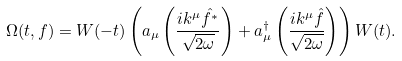Convert formula to latex. <formula><loc_0><loc_0><loc_500><loc_500>\Omega ( t , f ) = W ( - t ) \left ( a _ { \mu } \left ( \frac { i k ^ { \mu } \hat { f ^ { * } } } { \sqrt { 2 \omega } } \right ) + a _ { \mu } ^ { \dagger } \left ( \frac { i k ^ { \mu } \hat { f } } { \sqrt { 2 \omega } } \right ) \right ) W ( t ) .</formula> 